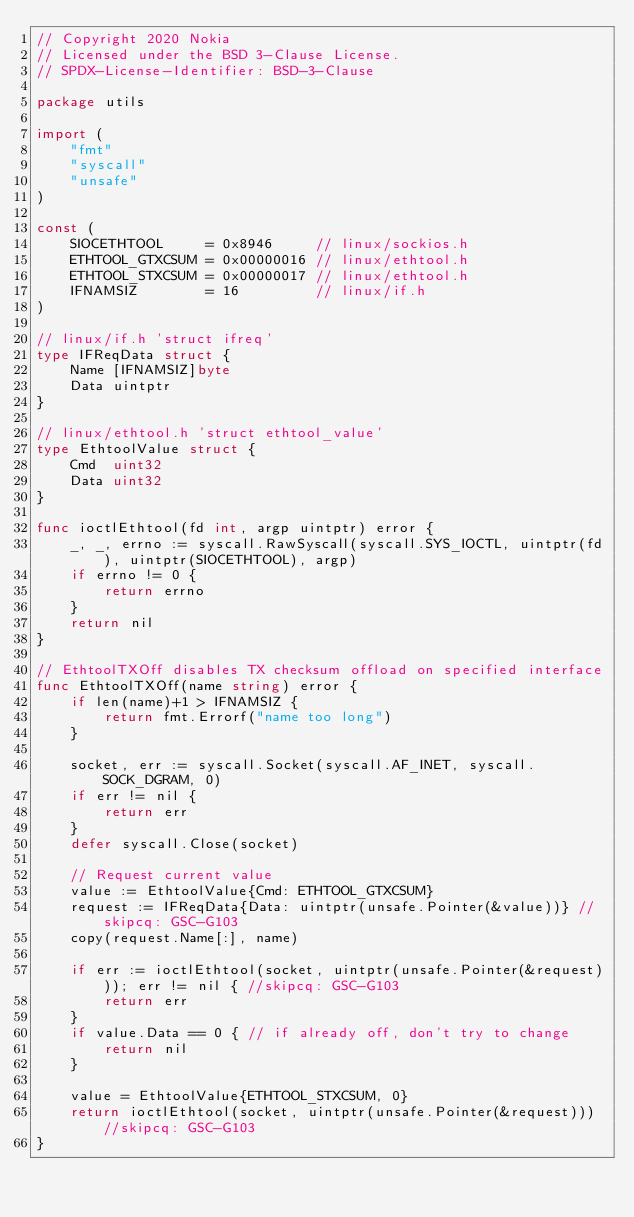Convert code to text. <code><loc_0><loc_0><loc_500><loc_500><_Go_>// Copyright 2020 Nokia
// Licensed under the BSD 3-Clause License.
// SPDX-License-Identifier: BSD-3-Clause

package utils

import (
	"fmt"
	"syscall"
	"unsafe"
)

const (
	SIOCETHTOOL     = 0x8946     // linux/sockios.h
	ETHTOOL_GTXCSUM = 0x00000016 // linux/ethtool.h
	ETHTOOL_STXCSUM = 0x00000017 // linux/ethtool.h
	IFNAMSIZ        = 16         // linux/if.h
)

// linux/if.h 'struct ifreq'
type IFReqData struct {
	Name [IFNAMSIZ]byte
	Data uintptr
}

// linux/ethtool.h 'struct ethtool_value'
type EthtoolValue struct {
	Cmd  uint32
	Data uint32
}

func ioctlEthtool(fd int, argp uintptr) error {
	_, _, errno := syscall.RawSyscall(syscall.SYS_IOCTL, uintptr(fd), uintptr(SIOCETHTOOL), argp)
	if errno != 0 {
		return errno
	}
	return nil
}

// EthtoolTXOff disables TX checksum offload on specified interface
func EthtoolTXOff(name string) error {
	if len(name)+1 > IFNAMSIZ {
		return fmt.Errorf("name too long")
	}

	socket, err := syscall.Socket(syscall.AF_INET, syscall.SOCK_DGRAM, 0)
	if err != nil {
		return err
	}
	defer syscall.Close(socket)

	// Request current value
	value := EthtoolValue{Cmd: ETHTOOL_GTXCSUM}
	request := IFReqData{Data: uintptr(unsafe.Pointer(&value))} //skipcq: GSC-G103
	copy(request.Name[:], name)

	if err := ioctlEthtool(socket, uintptr(unsafe.Pointer(&request))); err != nil { //skipcq: GSC-G103
		return err
	}
	if value.Data == 0 { // if already off, don't try to change
		return nil
	}

	value = EthtoolValue{ETHTOOL_STXCSUM, 0}
	return ioctlEthtool(socket, uintptr(unsafe.Pointer(&request))) //skipcq: GSC-G103
}
</code> 